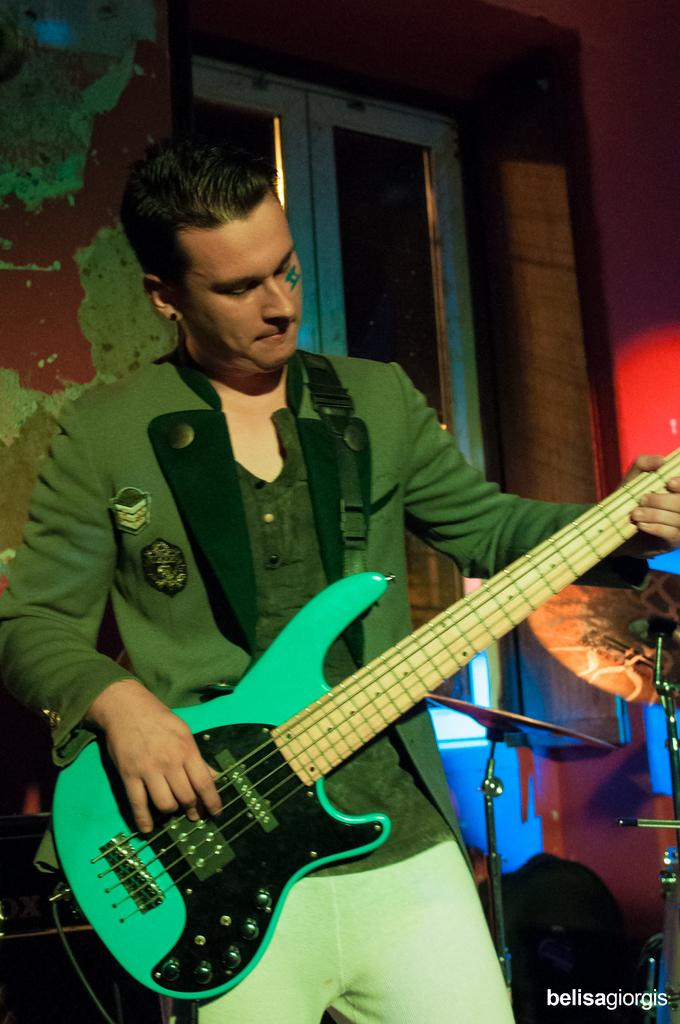Who is the person in the image? There is a man in the image. What is the man doing in the image? The man is playing a guitar. What other objects related to music can be seen in the image? There are musical instruments in the image. What can be seen in the background of the image? There is a wall and a window in the background of the image. What type of cloth is draped over the calendar in the image? There is no calendar or cloth present in the image. What impulse caused the man to start playing the guitar in the image? The image does not provide information about the man's motivation or impulse for playing the guitar. 